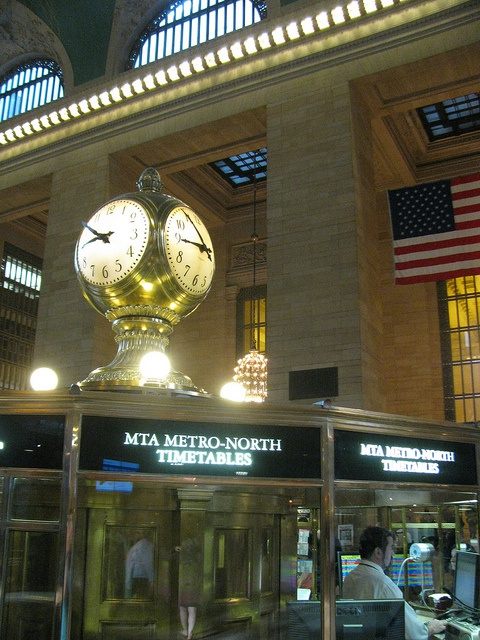Describe the objects in this image and their specific colors. I can see clock in black, ivory, khaki, tan, and gray tones, clock in black, khaki, ivory, olive, and tan tones, people in black, gray, and darkgray tones, people in black, darkgreen, and gray tones, and tv in black and gray tones in this image. 